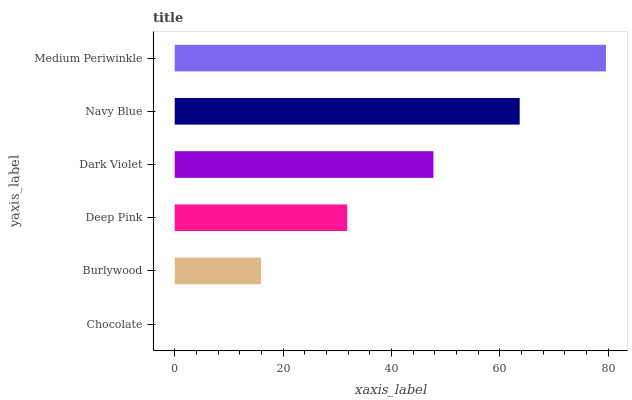Is Chocolate the minimum?
Answer yes or no. Yes. Is Medium Periwinkle the maximum?
Answer yes or no. Yes. Is Burlywood the minimum?
Answer yes or no. No. Is Burlywood the maximum?
Answer yes or no. No. Is Burlywood greater than Chocolate?
Answer yes or no. Yes. Is Chocolate less than Burlywood?
Answer yes or no. Yes. Is Chocolate greater than Burlywood?
Answer yes or no. No. Is Burlywood less than Chocolate?
Answer yes or no. No. Is Dark Violet the high median?
Answer yes or no. Yes. Is Deep Pink the low median?
Answer yes or no. Yes. Is Deep Pink the high median?
Answer yes or no. No. Is Burlywood the low median?
Answer yes or no. No. 